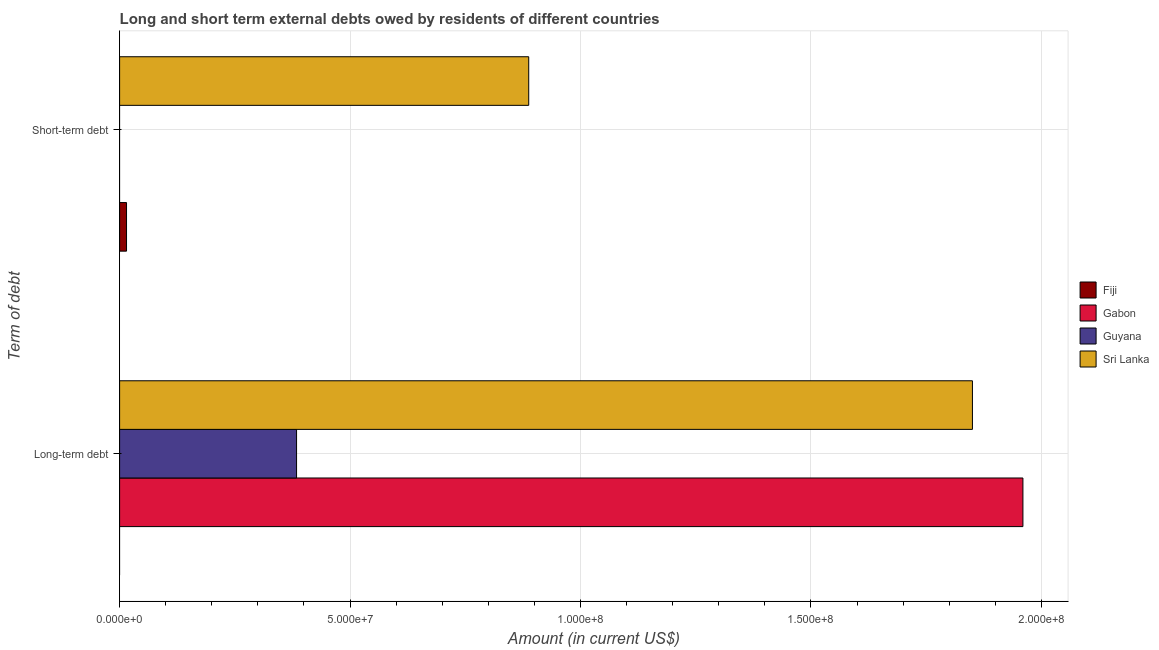How many different coloured bars are there?
Your answer should be very brief. 4. Are the number of bars per tick equal to the number of legend labels?
Provide a short and direct response. No. Are the number of bars on each tick of the Y-axis equal?
Ensure brevity in your answer.  No. How many bars are there on the 1st tick from the top?
Your response must be concise. 2. How many bars are there on the 1st tick from the bottom?
Keep it short and to the point. 3. What is the label of the 2nd group of bars from the top?
Ensure brevity in your answer.  Long-term debt. What is the long-term debts owed by residents in Sri Lanka?
Provide a short and direct response. 1.85e+08. Across all countries, what is the maximum long-term debts owed by residents?
Offer a terse response. 1.96e+08. In which country was the long-term debts owed by residents maximum?
Your answer should be compact. Gabon. What is the total short-term debts owed by residents in the graph?
Your response must be concise. 9.03e+07. What is the difference between the long-term debts owed by residents in Guyana and that in Sri Lanka?
Make the answer very short. -1.47e+08. What is the difference between the short-term debts owed by residents in Gabon and the long-term debts owed by residents in Sri Lanka?
Your response must be concise. -1.85e+08. What is the average long-term debts owed by residents per country?
Offer a terse response. 1.05e+08. What is the difference between the long-term debts owed by residents and short-term debts owed by residents in Sri Lanka?
Offer a terse response. 9.63e+07. In how many countries, is the long-term debts owed by residents greater than 150000000 US$?
Provide a short and direct response. 2. What is the ratio of the short-term debts owed by residents in Fiji to that in Sri Lanka?
Offer a very short reply. 0.02. How many bars are there?
Give a very brief answer. 5. What is the difference between two consecutive major ticks on the X-axis?
Make the answer very short. 5.00e+07. Does the graph contain any zero values?
Provide a succinct answer. Yes. Where does the legend appear in the graph?
Your answer should be compact. Center right. How many legend labels are there?
Provide a short and direct response. 4. What is the title of the graph?
Ensure brevity in your answer.  Long and short term external debts owed by residents of different countries. Does "Guyana" appear as one of the legend labels in the graph?
Your answer should be very brief. Yes. What is the label or title of the Y-axis?
Keep it short and to the point. Term of debt. What is the Amount (in current US$) in Fiji in Long-term debt?
Your answer should be very brief. 0. What is the Amount (in current US$) of Gabon in Long-term debt?
Provide a short and direct response. 1.96e+08. What is the Amount (in current US$) in Guyana in Long-term debt?
Provide a short and direct response. 3.84e+07. What is the Amount (in current US$) in Sri Lanka in Long-term debt?
Your response must be concise. 1.85e+08. What is the Amount (in current US$) of Fiji in Short-term debt?
Your answer should be very brief. 1.50e+06. What is the Amount (in current US$) of Guyana in Short-term debt?
Your answer should be compact. 0. What is the Amount (in current US$) in Sri Lanka in Short-term debt?
Provide a succinct answer. 8.88e+07. Across all Term of debt, what is the maximum Amount (in current US$) in Fiji?
Keep it short and to the point. 1.50e+06. Across all Term of debt, what is the maximum Amount (in current US$) in Gabon?
Your answer should be compact. 1.96e+08. Across all Term of debt, what is the maximum Amount (in current US$) in Guyana?
Your answer should be very brief. 3.84e+07. Across all Term of debt, what is the maximum Amount (in current US$) of Sri Lanka?
Your answer should be very brief. 1.85e+08. Across all Term of debt, what is the minimum Amount (in current US$) in Sri Lanka?
Offer a terse response. 8.88e+07. What is the total Amount (in current US$) in Fiji in the graph?
Give a very brief answer. 1.50e+06. What is the total Amount (in current US$) in Gabon in the graph?
Offer a very short reply. 1.96e+08. What is the total Amount (in current US$) of Guyana in the graph?
Ensure brevity in your answer.  3.84e+07. What is the total Amount (in current US$) of Sri Lanka in the graph?
Give a very brief answer. 2.74e+08. What is the difference between the Amount (in current US$) of Sri Lanka in Long-term debt and that in Short-term debt?
Offer a terse response. 9.63e+07. What is the difference between the Amount (in current US$) of Gabon in Long-term debt and the Amount (in current US$) of Sri Lanka in Short-term debt?
Your answer should be very brief. 1.07e+08. What is the difference between the Amount (in current US$) of Guyana in Long-term debt and the Amount (in current US$) of Sri Lanka in Short-term debt?
Your answer should be compact. -5.04e+07. What is the average Amount (in current US$) of Fiji per Term of debt?
Your answer should be compact. 7.50e+05. What is the average Amount (in current US$) in Gabon per Term of debt?
Offer a very short reply. 9.80e+07. What is the average Amount (in current US$) of Guyana per Term of debt?
Make the answer very short. 1.92e+07. What is the average Amount (in current US$) of Sri Lanka per Term of debt?
Your answer should be compact. 1.37e+08. What is the difference between the Amount (in current US$) of Gabon and Amount (in current US$) of Guyana in Long-term debt?
Your answer should be very brief. 1.58e+08. What is the difference between the Amount (in current US$) of Gabon and Amount (in current US$) of Sri Lanka in Long-term debt?
Make the answer very short. 1.10e+07. What is the difference between the Amount (in current US$) of Guyana and Amount (in current US$) of Sri Lanka in Long-term debt?
Give a very brief answer. -1.47e+08. What is the difference between the Amount (in current US$) of Fiji and Amount (in current US$) of Sri Lanka in Short-term debt?
Your answer should be compact. -8.73e+07. What is the ratio of the Amount (in current US$) of Sri Lanka in Long-term debt to that in Short-term debt?
Ensure brevity in your answer.  2.08. What is the difference between the highest and the second highest Amount (in current US$) of Sri Lanka?
Give a very brief answer. 9.63e+07. What is the difference between the highest and the lowest Amount (in current US$) of Fiji?
Your response must be concise. 1.50e+06. What is the difference between the highest and the lowest Amount (in current US$) in Gabon?
Offer a terse response. 1.96e+08. What is the difference between the highest and the lowest Amount (in current US$) of Guyana?
Ensure brevity in your answer.  3.84e+07. What is the difference between the highest and the lowest Amount (in current US$) in Sri Lanka?
Provide a succinct answer. 9.63e+07. 